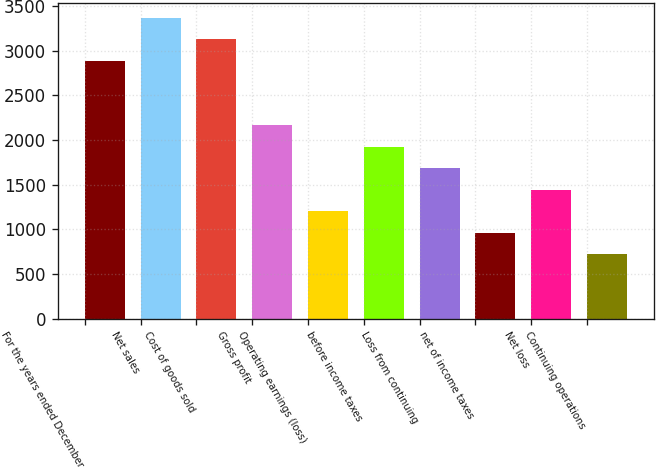Convert chart to OTSL. <chart><loc_0><loc_0><loc_500><loc_500><bar_chart><fcel>For the years ended December<fcel>Net sales<fcel>Cost of goods sold<fcel>Gross profit<fcel>Operating earnings (loss)<fcel>before income taxes<fcel>Loss from continuing<fcel>net of income taxes<fcel>Net loss<fcel>Continuing operations<nl><fcel>2887.1<fcel>3368.26<fcel>3127.68<fcel>2165.34<fcel>1202.99<fcel>1924.75<fcel>1684.16<fcel>962.41<fcel>1443.58<fcel>721.82<nl></chart> 